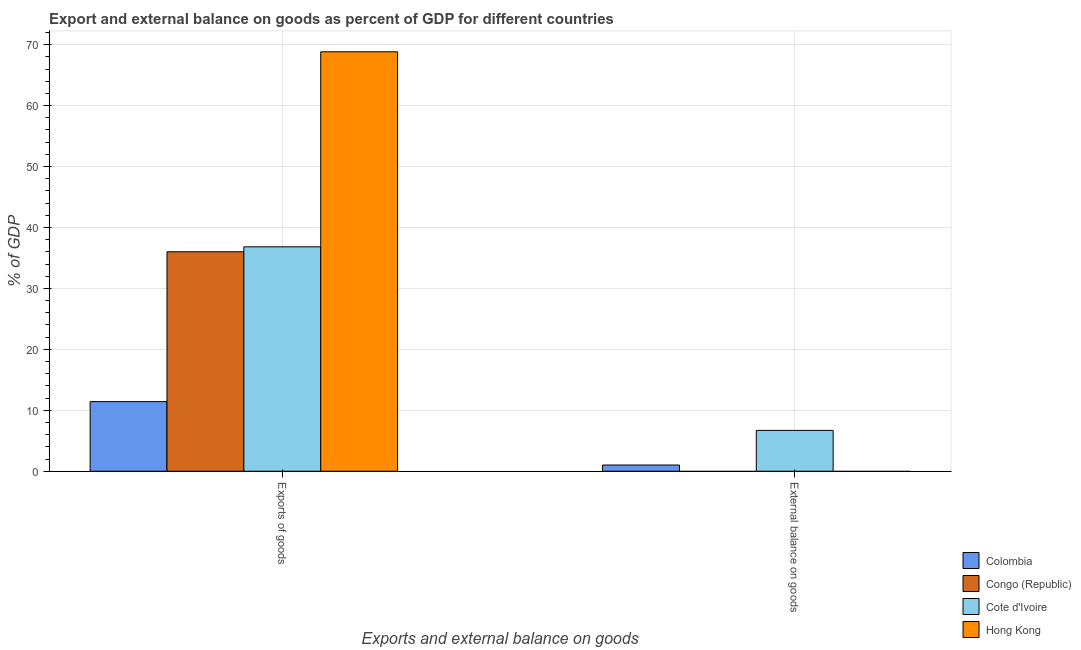How many different coloured bars are there?
Offer a very short reply. 4. How many groups of bars are there?
Ensure brevity in your answer.  2. Are the number of bars on each tick of the X-axis equal?
Your response must be concise. No. How many bars are there on the 1st tick from the left?
Offer a very short reply. 4. What is the label of the 2nd group of bars from the left?
Provide a short and direct response. External balance on goods. What is the external balance on goods as percentage of gdp in Cote d'Ivoire?
Provide a succinct answer. 6.7. Across all countries, what is the maximum external balance on goods as percentage of gdp?
Provide a succinct answer. 6.7. Across all countries, what is the minimum external balance on goods as percentage of gdp?
Ensure brevity in your answer.  0. In which country was the external balance on goods as percentage of gdp maximum?
Your response must be concise. Cote d'Ivoire. What is the total external balance on goods as percentage of gdp in the graph?
Provide a succinct answer. 7.72. What is the difference between the export of goods as percentage of gdp in Hong Kong and that in Congo (Republic)?
Your answer should be compact. 32.82. What is the difference between the export of goods as percentage of gdp in Congo (Republic) and the external balance on goods as percentage of gdp in Cote d'Ivoire?
Your answer should be very brief. 29.31. What is the average export of goods as percentage of gdp per country?
Give a very brief answer. 38.27. What is the difference between the export of goods as percentage of gdp and external balance on goods as percentage of gdp in Cote d'Ivoire?
Offer a very short reply. 30.12. What is the ratio of the export of goods as percentage of gdp in Congo (Republic) to that in Colombia?
Give a very brief answer. 3.15. Is the export of goods as percentage of gdp in Congo (Republic) less than that in Hong Kong?
Provide a short and direct response. Yes. In how many countries, is the external balance on goods as percentage of gdp greater than the average external balance on goods as percentage of gdp taken over all countries?
Offer a terse response. 1. How many bars are there?
Offer a terse response. 6. Are all the bars in the graph horizontal?
Make the answer very short. No. Are the values on the major ticks of Y-axis written in scientific E-notation?
Keep it short and to the point. No. Does the graph contain grids?
Give a very brief answer. Yes. Where does the legend appear in the graph?
Provide a short and direct response. Bottom right. How many legend labels are there?
Offer a terse response. 4. What is the title of the graph?
Provide a short and direct response. Export and external balance on goods as percent of GDP for different countries. What is the label or title of the X-axis?
Make the answer very short. Exports and external balance on goods. What is the label or title of the Y-axis?
Provide a short and direct response. % of GDP. What is the % of GDP of Colombia in Exports of goods?
Your answer should be compact. 11.42. What is the % of GDP of Congo (Republic) in Exports of goods?
Offer a terse response. 36.01. What is the % of GDP in Cote d'Ivoire in Exports of goods?
Provide a short and direct response. 36.82. What is the % of GDP of Hong Kong in Exports of goods?
Make the answer very short. 68.82. What is the % of GDP of Colombia in External balance on goods?
Provide a short and direct response. 1.02. What is the % of GDP in Cote d'Ivoire in External balance on goods?
Make the answer very short. 6.7. Across all Exports and external balance on goods, what is the maximum % of GDP in Colombia?
Offer a terse response. 11.42. Across all Exports and external balance on goods, what is the maximum % of GDP in Congo (Republic)?
Your answer should be compact. 36.01. Across all Exports and external balance on goods, what is the maximum % of GDP of Cote d'Ivoire?
Provide a succinct answer. 36.82. Across all Exports and external balance on goods, what is the maximum % of GDP in Hong Kong?
Keep it short and to the point. 68.82. Across all Exports and external balance on goods, what is the minimum % of GDP in Colombia?
Give a very brief answer. 1.02. Across all Exports and external balance on goods, what is the minimum % of GDP in Cote d'Ivoire?
Make the answer very short. 6.7. Across all Exports and external balance on goods, what is the minimum % of GDP of Hong Kong?
Provide a succinct answer. 0. What is the total % of GDP in Colombia in the graph?
Keep it short and to the point. 12.44. What is the total % of GDP of Congo (Republic) in the graph?
Your answer should be very brief. 36.01. What is the total % of GDP of Cote d'Ivoire in the graph?
Provide a succinct answer. 43.52. What is the total % of GDP of Hong Kong in the graph?
Provide a short and direct response. 68.82. What is the difference between the % of GDP in Colombia in Exports of goods and that in External balance on goods?
Your answer should be compact. 10.4. What is the difference between the % of GDP of Cote d'Ivoire in Exports of goods and that in External balance on goods?
Make the answer very short. 30.12. What is the difference between the % of GDP of Colombia in Exports of goods and the % of GDP of Cote d'Ivoire in External balance on goods?
Provide a succinct answer. 4.72. What is the difference between the % of GDP in Congo (Republic) in Exports of goods and the % of GDP in Cote d'Ivoire in External balance on goods?
Ensure brevity in your answer.  29.31. What is the average % of GDP of Colombia per Exports and external balance on goods?
Keep it short and to the point. 6.22. What is the average % of GDP of Congo (Republic) per Exports and external balance on goods?
Provide a short and direct response. 18. What is the average % of GDP of Cote d'Ivoire per Exports and external balance on goods?
Your response must be concise. 21.76. What is the average % of GDP in Hong Kong per Exports and external balance on goods?
Your response must be concise. 34.41. What is the difference between the % of GDP in Colombia and % of GDP in Congo (Republic) in Exports of goods?
Ensure brevity in your answer.  -24.59. What is the difference between the % of GDP of Colombia and % of GDP of Cote d'Ivoire in Exports of goods?
Your answer should be very brief. -25.4. What is the difference between the % of GDP of Colombia and % of GDP of Hong Kong in Exports of goods?
Provide a short and direct response. -57.4. What is the difference between the % of GDP of Congo (Republic) and % of GDP of Cote d'Ivoire in Exports of goods?
Your response must be concise. -0.82. What is the difference between the % of GDP of Congo (Republic) and % of GDP of Hong Kong in Exports of goods?
Make the answer very short. -32.82. What is the difference between the % of GDP in Cote d'Ivoire and % of GDP in Hong Kong in Exports of goods?
Offer a terse response. -32. What is the difference between the % of GDP in Colombia and % of GDP in Cote d'Ivoire in External balance on goods?
Offer a terse response. -5.68. What is the ratio of the % of GDP of Colombia in Exports of goods to that in External balance on goods?
Your answer should be very brief. 11.22. What is the ratio of the % of GDP in Cote d'Ivoire in Exports of goods to that in External balance on goods?
Make the answer very short. 5.5. What is the difference between the highest and the second highest % of GDP of Colombia?
Ensure brevity in your answer.  10.4. What is the difference between the highest and the second highest % of GDP of Cote d'Ivoire?
Your response must be concise. 30.12. What is the difference between the highest and the lowest % of GDP in Colombia?
Your response must be concise. 10.4. What is the difference between the highest and the lowest % of GDP in Congo (Republic)?
Your answer should be very brief. 36.01. What is the difference between the highest and the lowest % of GDP in Cote d'Ivoire?
Provide a succinct answer. 30.12. What is the difference between the highest and the lowest % of GDP of Hong Kong?
Your answer should be compact. 68.82. 